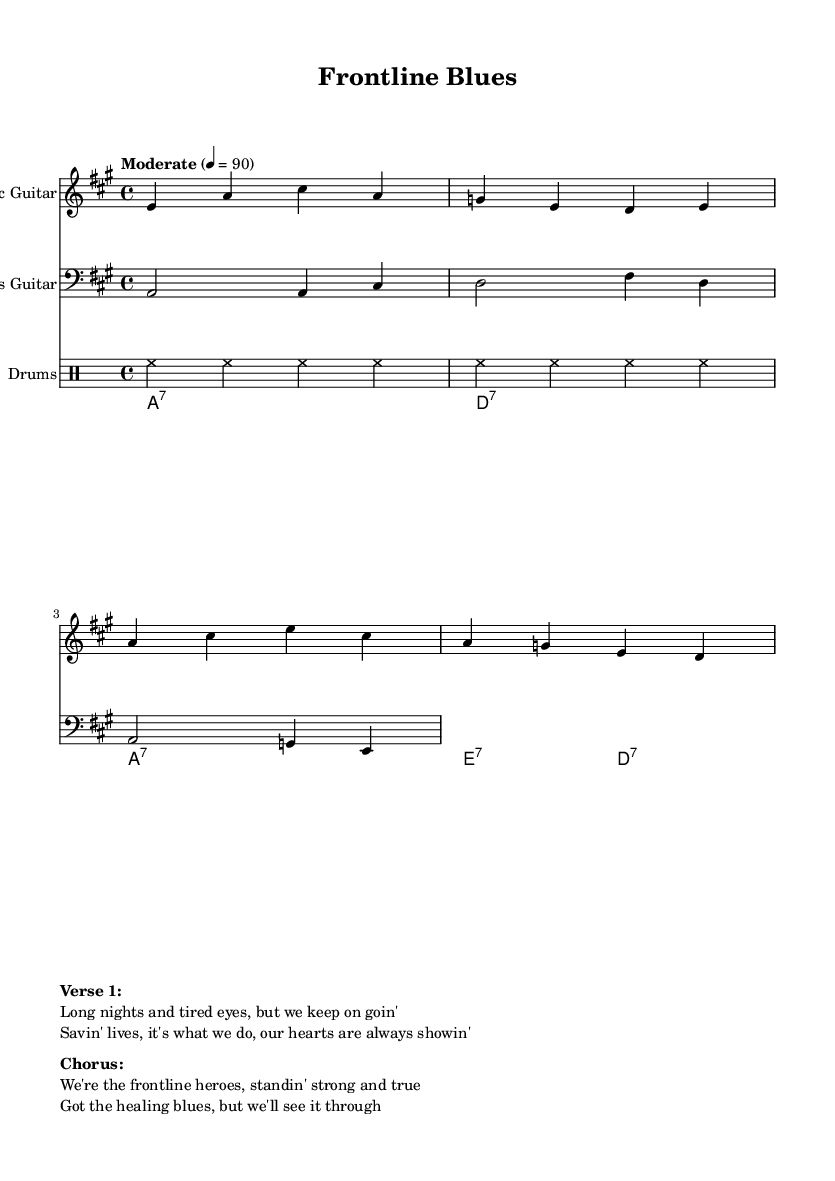What is the key signature of this music? The key signature is A major, which contains three sharps: F♯, C♯, and G♯. This can be determined by looking at the global context where the key is specified.
Answer: A major What is the time signature of this music? The time signature is 4/4, which indicates four beats in a measure and a quarter note receives one beat. This is evident from the global section where the time signature is stated.
Answer: 4/4 What is the tempo marking for this piece? The tempo marking is "Moderate" set to 90 beats per minute as mentioned in the global section of the code. This gives guidance on the speed at which the piece should be performed.
Answer: Moderate How many measures are in the electric guitar part? The electric guitar part contains four measures, which can be counted from the notes provided in the music for the guitar section.
Answer: Four What instruments are used in this sheet music? The instruments included are Electric Guitar, Bass Guitar, Drums, and Hammond Organ, as listed clearly at the beginning of each instrument section.
Answer: Electric Guitar, Bass Guitar, Drums, Hammond Organ Identify a theme present in the lyrics. The theme present in the lyrics focuses on resilience and dedication of healthcare workers, as expressed in phrases emphasizing their commitment to saving lives despite challenges. This is derived from the content of the verses and chorus which mention being "frontline heroes."
Answer: Resilience and dedication How does the structure of the music reflect Electric Blues? The structure reflects Electric Blues through the use of a call-and-response style where the verses and chorus communicate emotions and narratives typical of the Electric Blues genre. The combination of guitar riffs and expressive lyrics embodies the style.
Answer: Call-and-response structure 